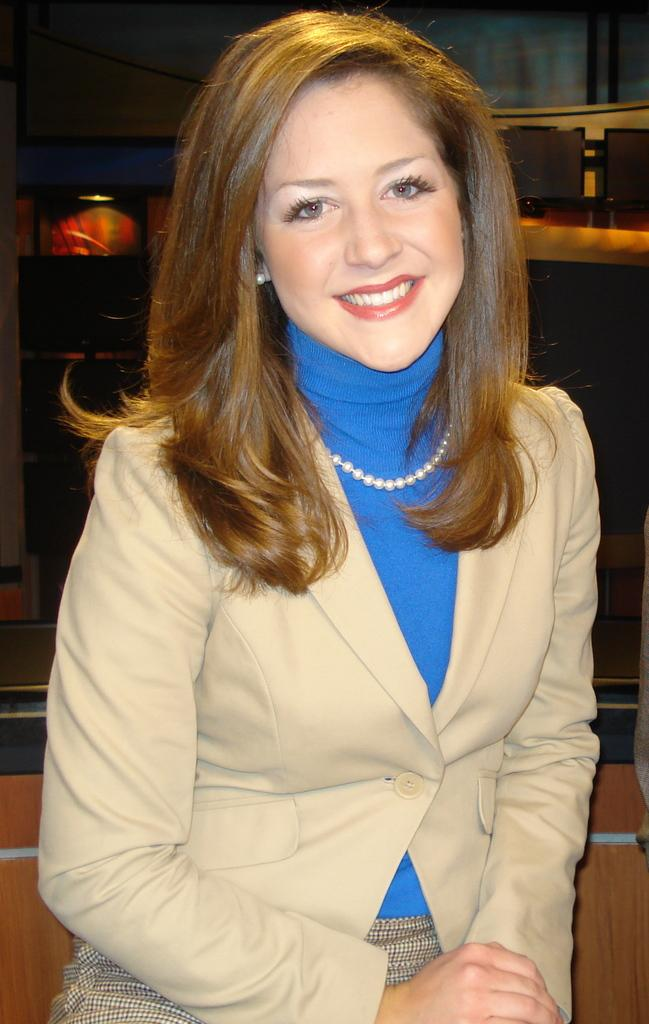Who is the main subject in the image? There is a woman in the image. What is the woman doing in the image? The woman is sitting. What accessory is the woman wearing in the image? The woman is wearing a necklace. What type of pickle is the woman holding in the image? There is no pickle present in the image. Is the woman engaged in a battle in the image? There is no indication of a battle or any conflict in the image. 